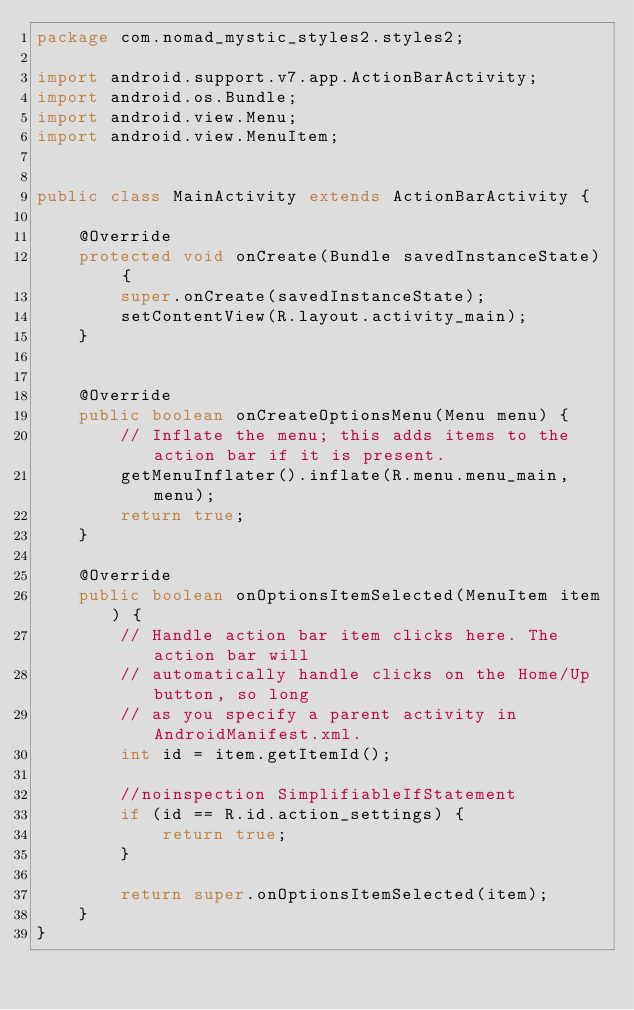Convert code to text. <code><loc_0><loc_0><loc_500><loc_500><_Java_>package com.nomad_mystic_styles2.styles2;

import android.support.v7.app.ActionBarActivity;
import android.os.Bundle;
import android.view.Menu;
import android.view.MenuItem;


public class MainActivity extends ActionBarActivity {

    @Override
    protected void onCreate(Bundle savedInstanceState) {
        super.onCreate(savedInstanceState);
        setContentView(R.layout.activity_main);
    }


    @Override
    public boolean onCreateOptionsMenu(Menu menu) {
        // Inflate the menu; this adds items to the action bar if it is present.
        getMenuInflater().inflate(R.menu.menu_main, menu);
        return true;
    }

    @Override
    public boolean onOptionsItemSelected(MenuItem item) {
        // Handle action bar item clicks here. The action bar will
        // automatically handle clicks on the Home/Up button, so long
        // as you specify a parent activity in AndroidManifest.xml.
        int id = item.getItemId();

        //noinspection SimplifiableIfStatement
        if (id == R.id.action_settings) {
            return true;
        }

        return super.onOptionsItemSelected(item);
    }
}
</code> 